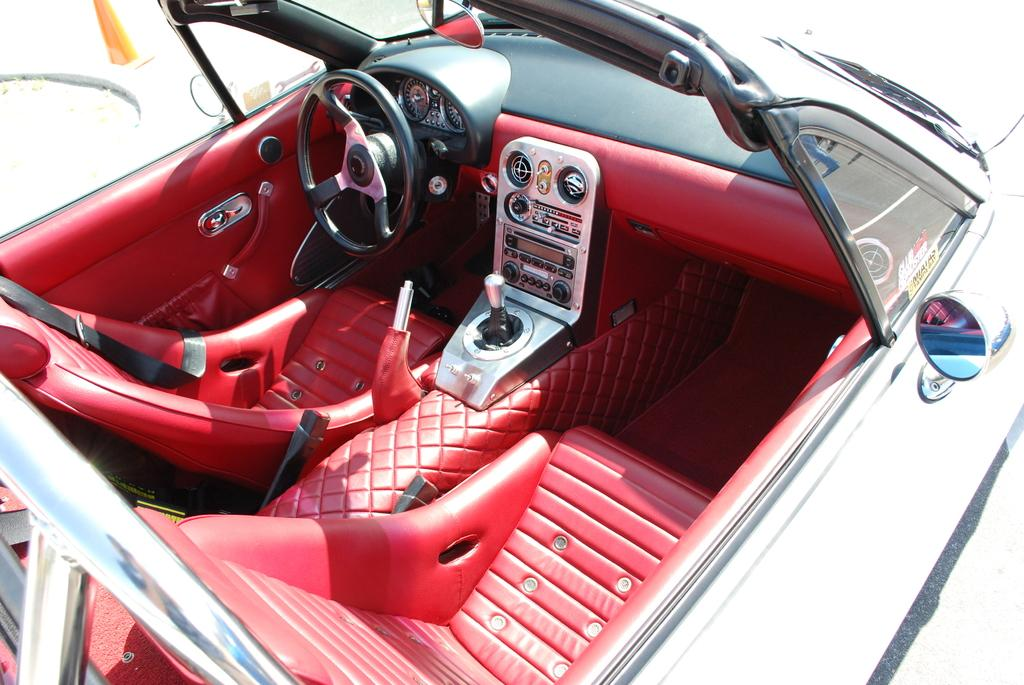What type of vehicle is shown in the image? The image provides an inner view of a car. What can be seen inside the car? The specific details of the car's interior are not mentioned in the facts provided. However, we can assume that it includes seats, a steering wheel, and various controls and features. Where is the frog taking a bath in the image? There is no frog or bath present in the image; it shows the interior of a car. 